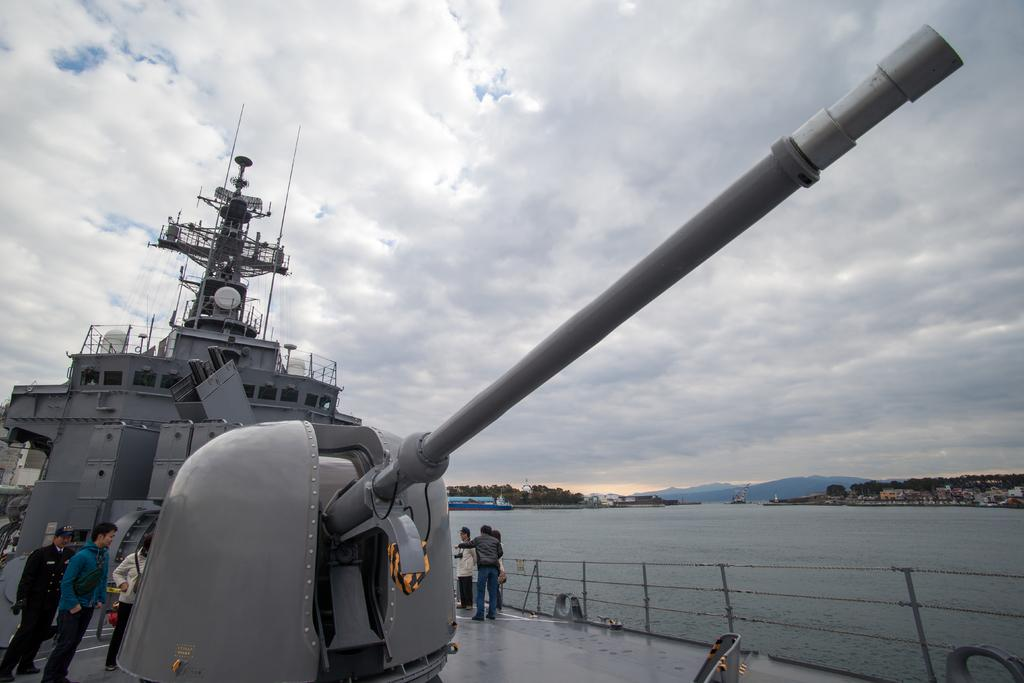What is the main subject in the foreground of the image? There is a ship in the foreground of the image. What can be seen on the ship? There are people on the ship. What is visible in the background of the image? Water, greenery, buildings, mountains, and the sky are visible in the background of the image. What is the condition of the sky in the image? The sky is visible in the background of the image, and there are clouds present. What type of furniture is visible on the ship in the image? There is no furniture visible on the ship in the image. What kind of structure is present on the mountains in the background of the image? There is no structure visible on the mountains in the background of the image. 